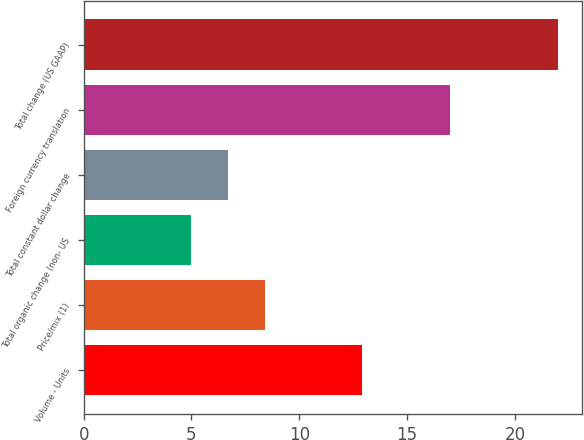Convert chart. <chart><loc_0><loc_0><loc_500><loc_500><bar_chart><fcel>Volume - Units<fcel>Price/mix (1)<fcel>Total organic change (non- US<fcel>Total constant dollar change<fcel>Foreign currency translation<fcel>Total change (US GAAP)<nl><fcel>12.9<fcel>8.4<fcel>5<fcel>6.7<fcel>17<fcel>22<nl></chart> 